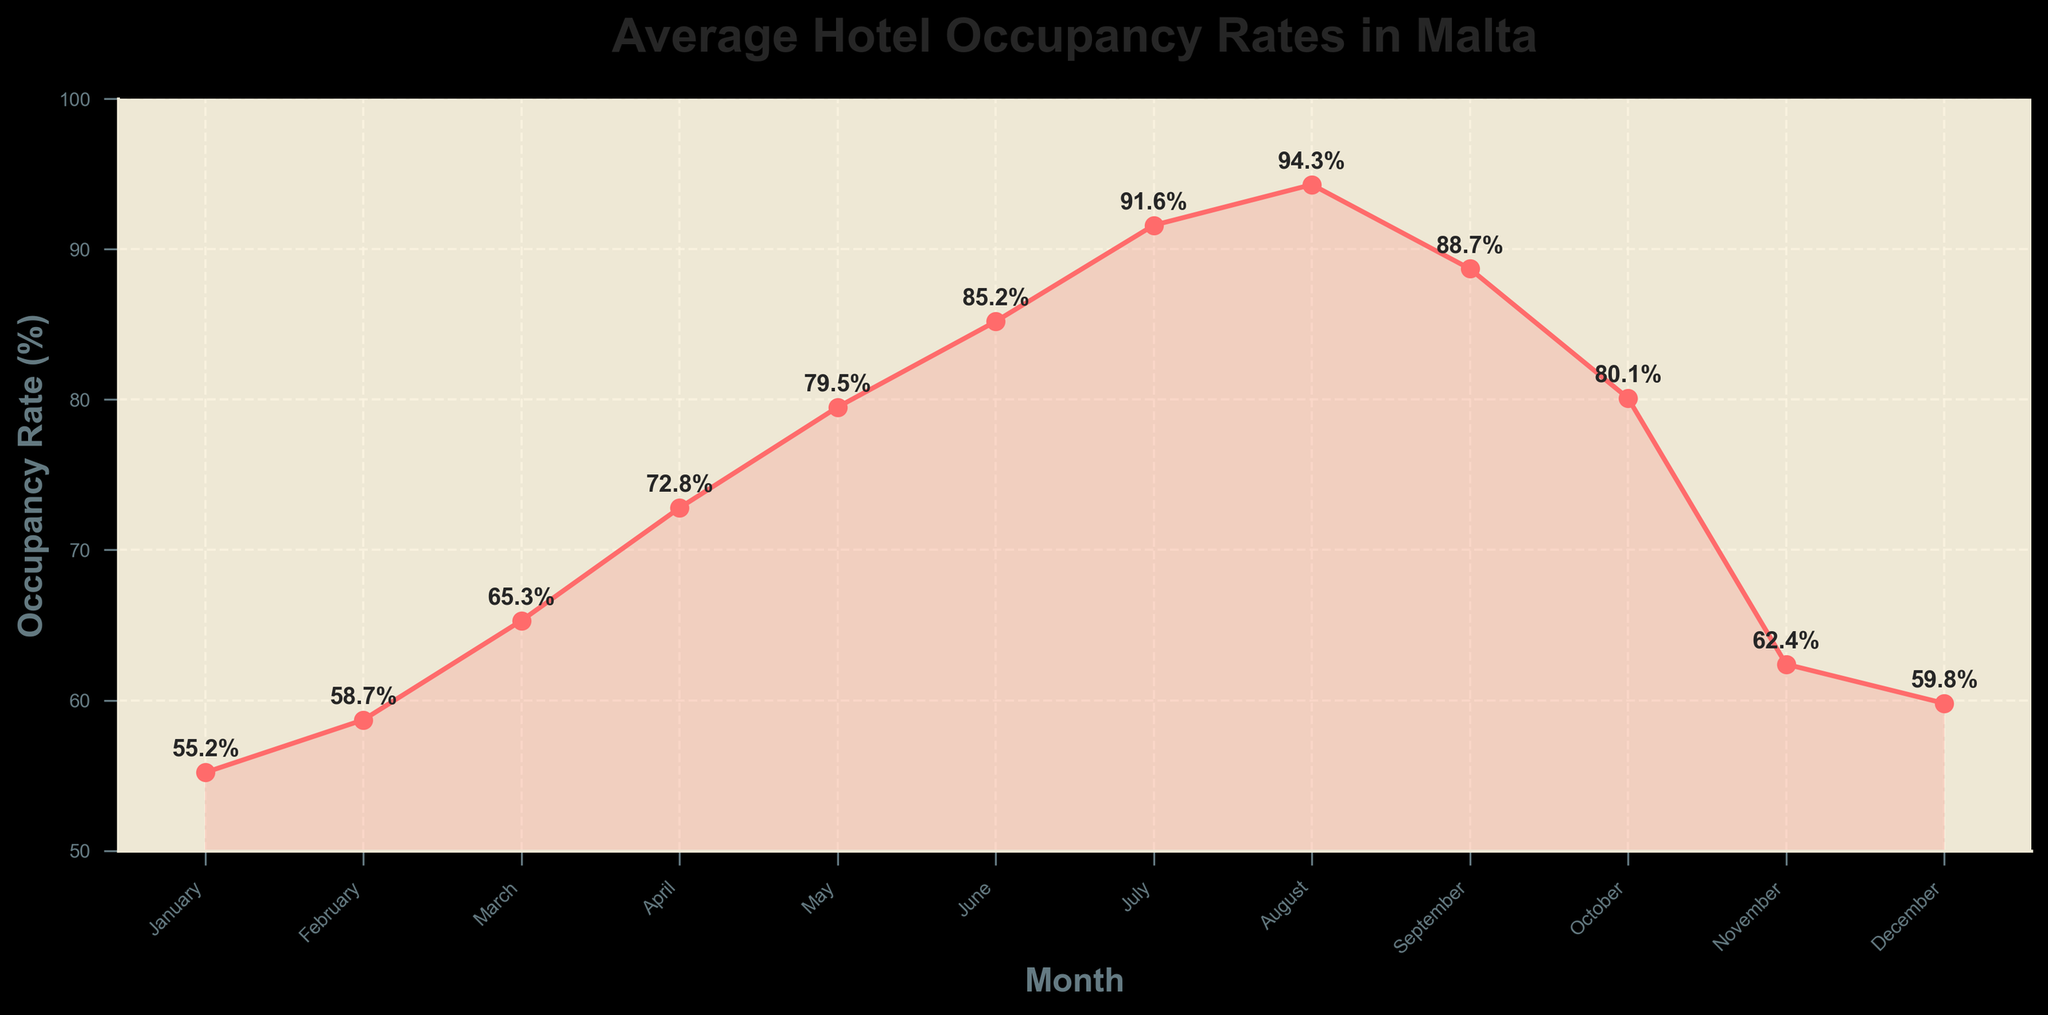What's the peak month for hotel occupancy rates in Malta? The peak month can be identified by looking for the highest point on the line plot. In this chart, the highest occupancy rate is in August.
Answer: August What is the difference in hotel occupancy rates between January and August? To calculate the difference, subtract the occupancy rate of January from that of August. The occupancy rates are 94.3% and 55.2% respectively. Therefore, 94.3 - 55.2 = 39.1.
Answer: 39.1% During which months is the hotel occupancy rate higher than 90%? By examining the plot, the points higher than the 90% line occur in July and August.
Answer: July and August What is the average hotel occupancy rate for the summer months (June, July, August)? The rates for June, July, and August are 85.2%, 91.6%, and 94.3%, respectively. To find the average: (85.2 + 91.6 + 94.3) / 3 = 271.1 / 3 = 90.37%.
Answer: 90.37% Compare the hotel occupancy rates in November and April. Which month has a higher rate and by how much? November has an occupancy rate of 62.4%, while April has 72.8%. Subtract November's rate from April's: 72.8 - 62.4 = 10.4. April's rate is higher by 10.4%.
Answer: April, 10.4% What's the trend in hotel occupancy rates from January to August? From January to August, the trend shows a consistent increase in occupancy rates, peaking in August.
Answer: Increasing What is the average occupancy rate for the first quarter (January, February, March)? The occupancy rates for January, February, and March are 55.2%, 58.7%, and 65.3% respectively. Calculate the average: (55.2 + 58.7 + 65.3) / 3 = 179.2 / 3 = 59.73%.
Answer: 59.73% Identify two consecutive months where there is a visible drop in occupancy rates. A visible drop occurs between October (80.1%) and November (62.4%).
Answer: October to November During which month does the occupancy rate rise the fastest? The fastest rise can be found by looking at the steepest upward slope on the plot. The steep rise is between February (58.7%) and March (65.3%).
Answer: March What is the range of occupancy rates observed throughout the year? The occupancy rate range is found by subtracting the smallest value from the largest value. The highest occupancy rate is 94.3% (August) and the lowest is 55.2% (January). Therefore, the range is 94.3 - 55.2 = 39.1%.
Answer: 39.1% 